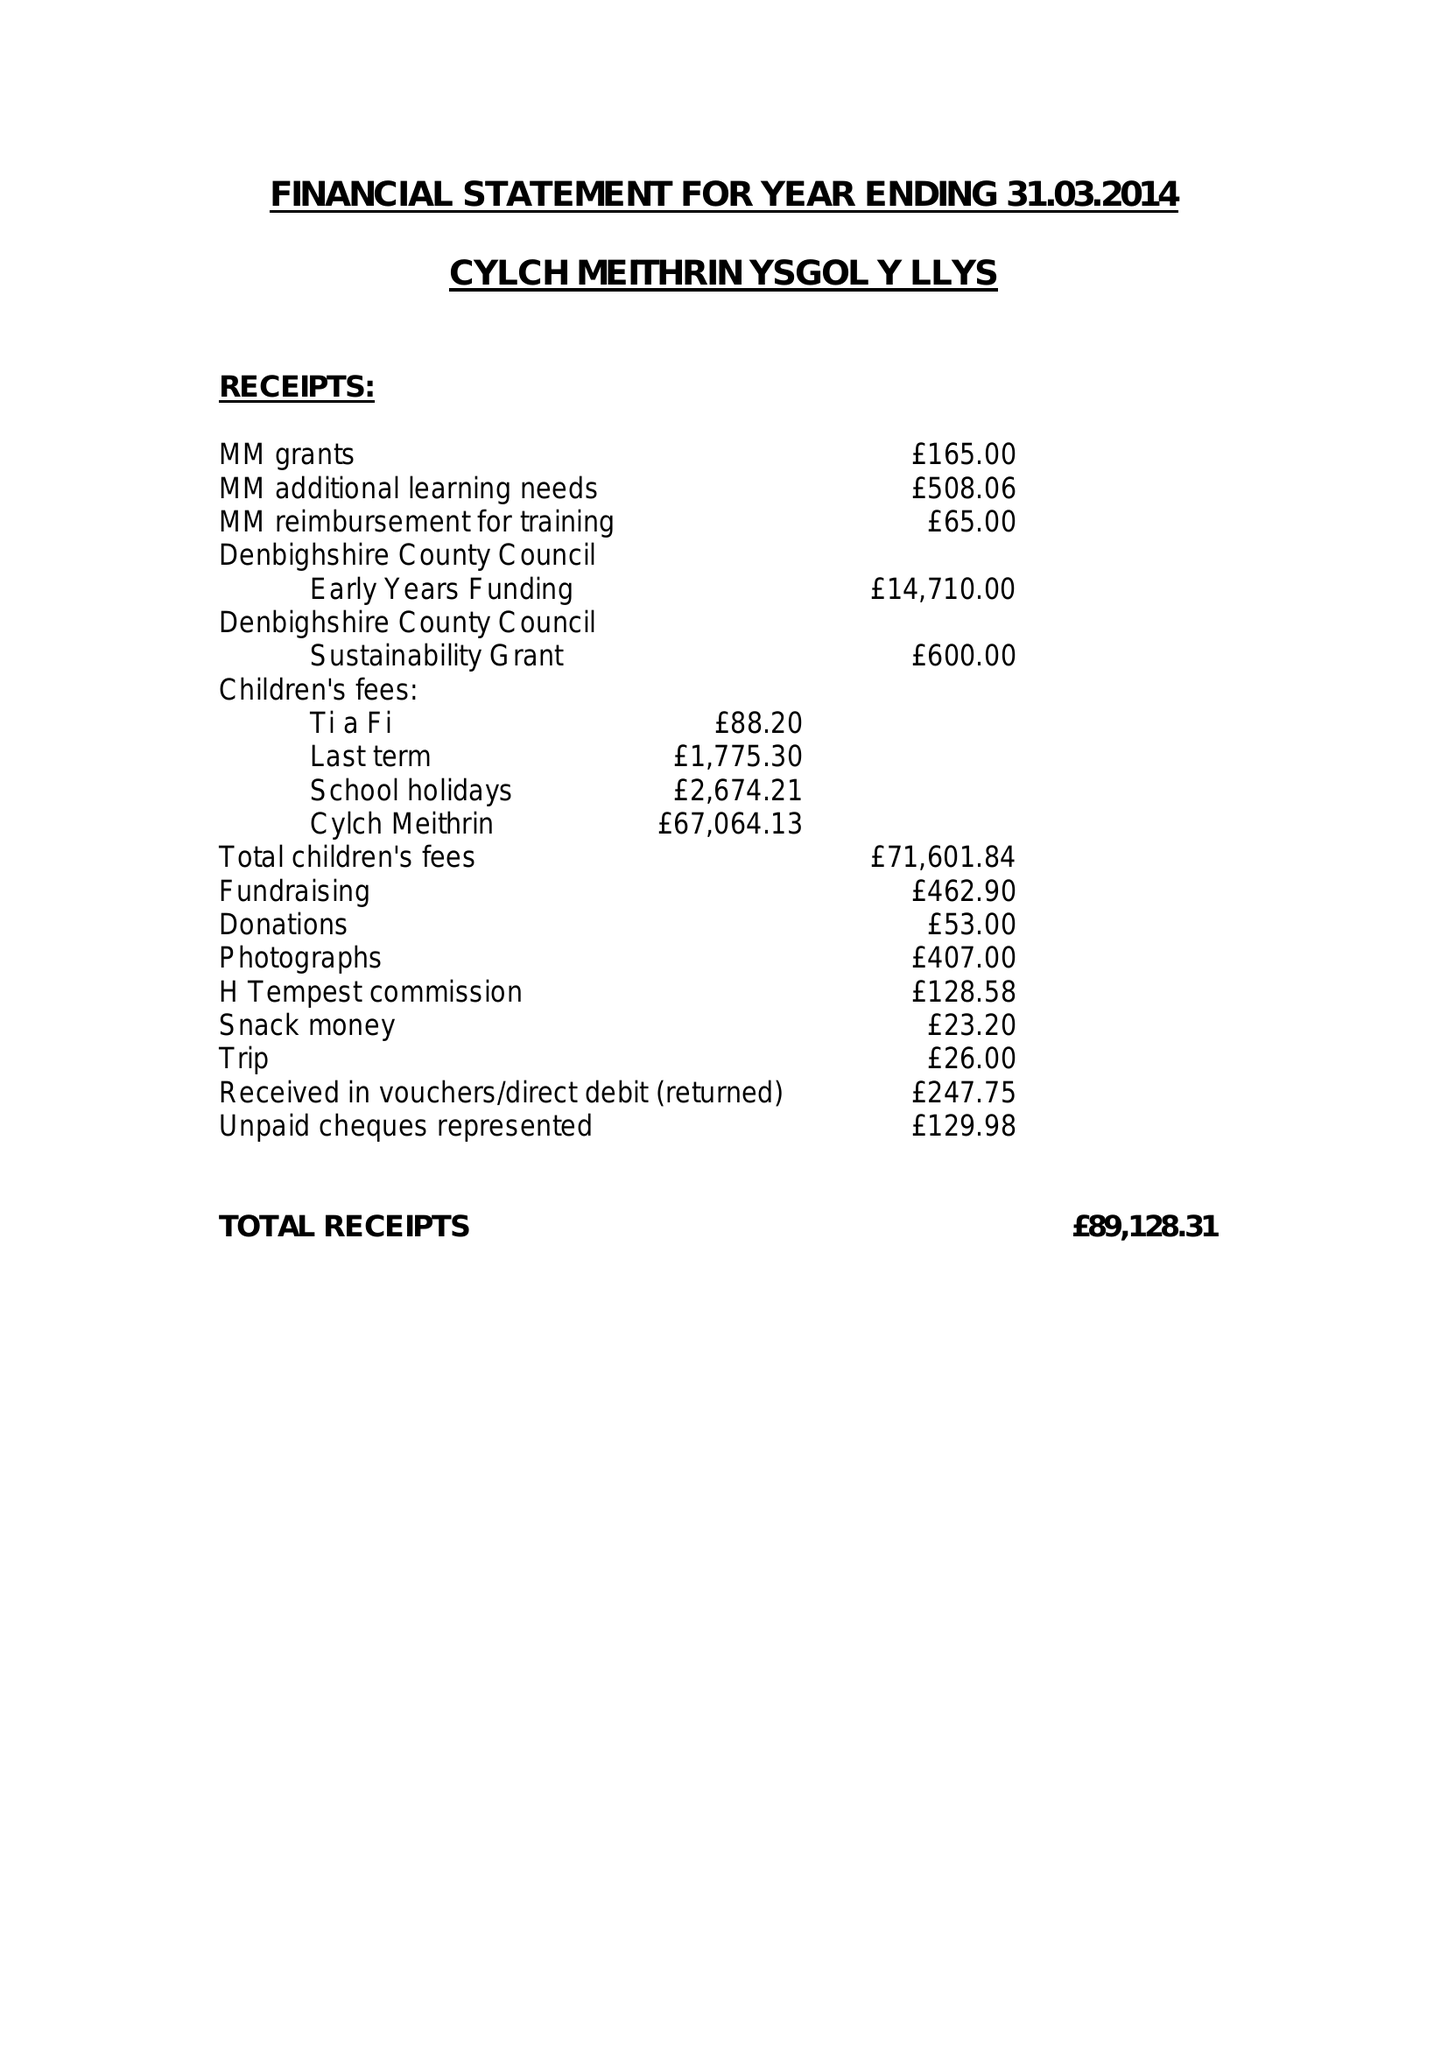What is the value for the address__post_town?
Answer the question using a single word or phrase. PRESTATYN 